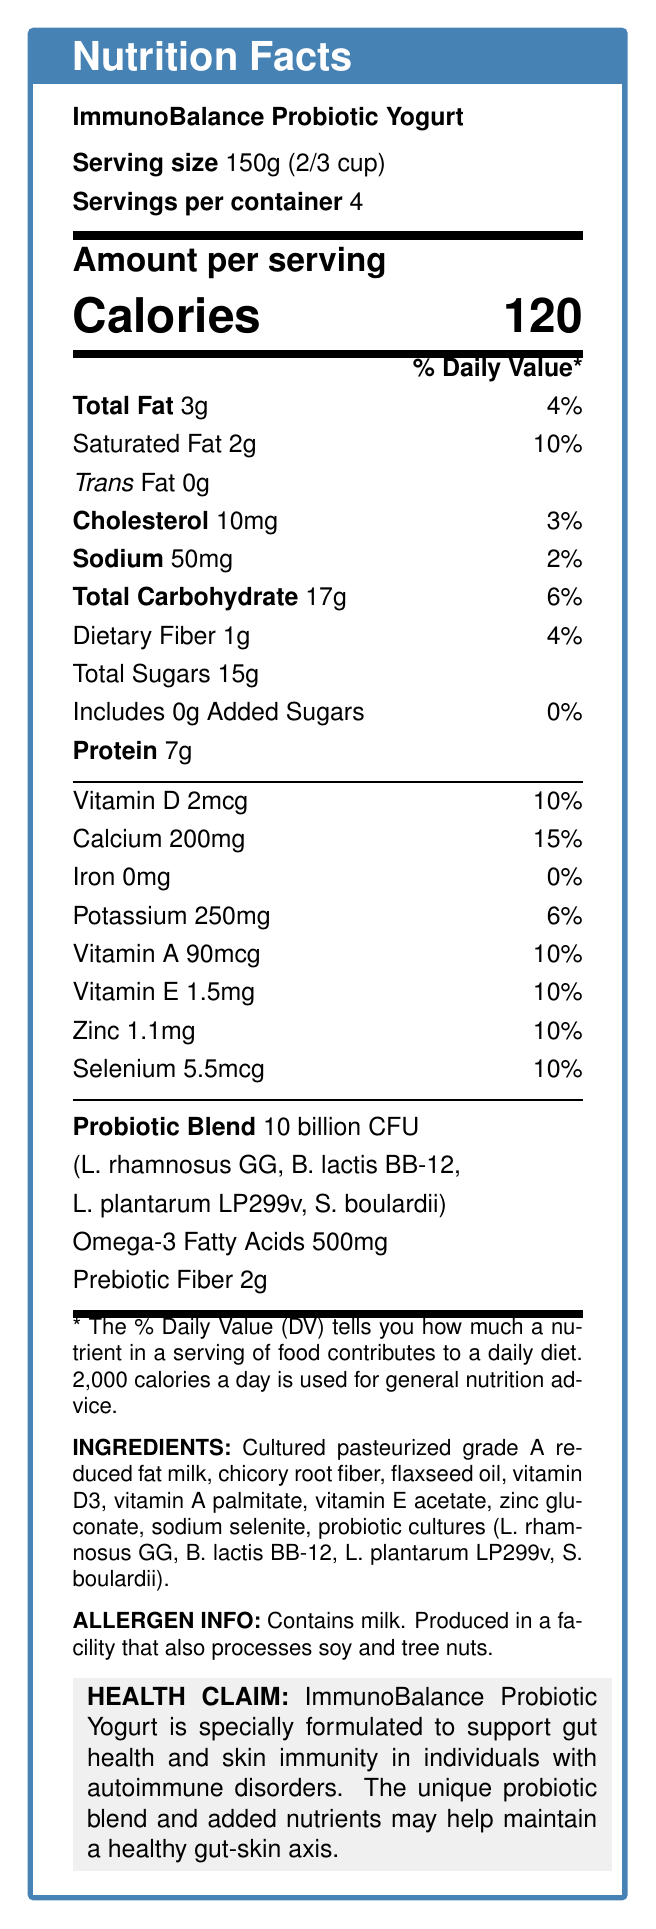what is the serving size of the ImmunoBalance Probiotic Yogurt? The serving size is specified at the beginning of the nutrition facts label.
Answer: 150g (2/3 cup) How many calories are there in one serving of the ImmunoBalance Probiotic Yogurt? The number of calories per serving is listed prominently under the "Amount per serving" section.
Answer: 120 what is the total fat content per serving? The total fat content is listed under the "Total Fat" label.
Answer: 3g What is the main purpose of the ImmunoBalance Probiotic Yogurt as stated in the health claim? The health claim clearly states that the product is specially formulated to support gut health and skin immunity in individuals with autoimmune disorders.
Answer: to support gut health and skin immunity in individuals with autoimmune disorders How many servings are in one container of ImmunoBalance Probiotic Yogurt? The number of servings per container is listed near the top of the document.
Answer: 4 what are the four strains of probiotics included in the ImmunoBalance Probiotic Yogurt? These strains are listed under the "Probiotic Blend" section.
Answer: Lactobacillus rhamnosus GG, Bifidobacterium lactis BB-12, Lactobacillus plantarum LP299v, Saccharomyces boulardii Which vitamin is present in the highest amount per serving in terms of percent daily value? A. Vitamin A B. Vitamin D C. Vitamin E D. Selenium Vitamin D is present at 10% daily value, which is the highest percent daily value listed among the vitamins.
Answer: Vitamin D How much dietary fiber is in one serving? A. 2g B. 4g C. 1g D. 0g The dietary fiber content is listed as 1g per serving.
Answer: 1g Does the product contain any information about iron content? The document states that iron content is 0mg per serving with a 0% daily value.
Answer: Yes Is this product suitable for individuals with a milk allergy? The allergen information states that the product contains milk.
Answer: No Summarize the main features of the ImmunoBalance Probiotic Yogurt. This summary provides an overview of the product's intended health benefits, serving size, calorie content, key ingredients, and allergen information.
Answer: ImmunoBalance Probiotic Yogurt is specially formulated to support gut health and skin immunity in individuals with autoimmune disorders. It contains a blend of probiotics, omega-3 fatty acids, prebiotic fiber, and essential vitamins and minerals. Each serving is 150g, provides 120 calories, and includes beneficial nutrients and probiotic strains that may help maintain a healthy gut-skin axis. The product has allergen information for those who are allergic to milk. what is the total amount of sugars per serving, including added sugars? The document lists total sugars as 15g and includes 0g of added sugars.
Answer: 15g What is the main ingredient of ImmunoBalance Probiotic Yogurt? The main ingredient is listed first in the ingredients section.
Answer: Cultured pasteurized grade A reduced fat milk How much omega-3 fatty acids are included in each serving? The omega-3 fatty acids content is clearly listed in the document.
Answer: 500mg Where is the product produced according to the allergen information? The allergen information states that the yogurt is produced in a facility that also processes soy and tree nuts.
Answer: in a facility that also processes soy and tree nuts What is the function of the chicory root fiber in this product? The document does not contain information regarding the specific function of chicory root fiber in the product.
Answer: Cannot be determined 